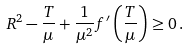<formula> <loc_0><loc_0><loc_500><loc_500>R ^ { 2 } - \frac { T } { \mu } + \frac { 1 } { \mu ^ { 2 } } f ^ { \prime } \left ( \frac { T } { \mu } \right ) \geq 0 \, .</formula> 